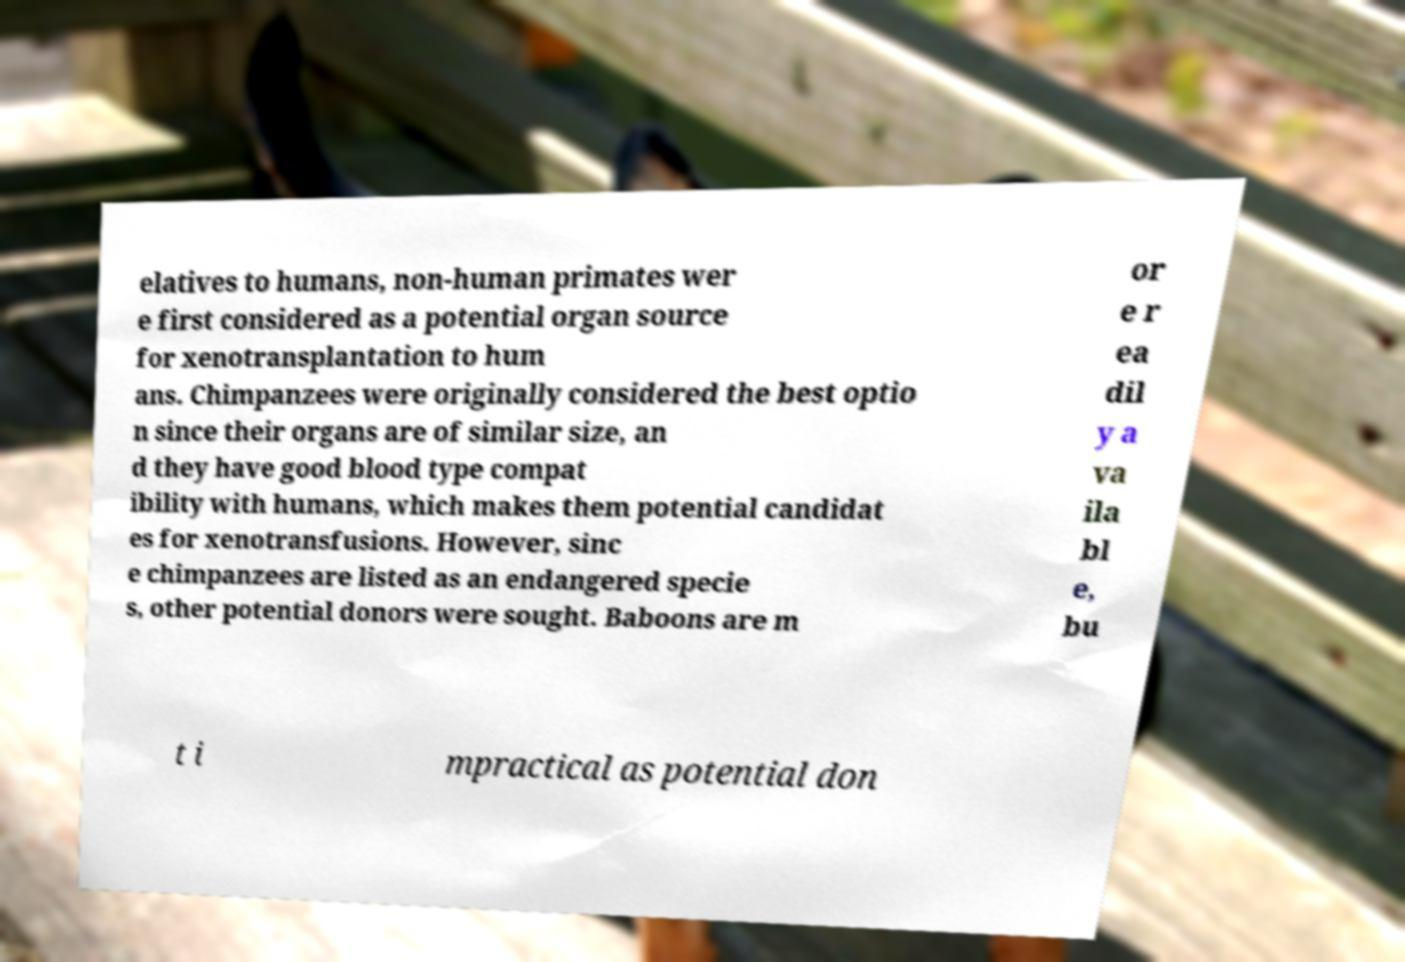For documentation purposes, I need the text within this image transcribed. Could you provide that? elatives to humans, non-human primates wer e first considered as a potential organ source for xenotransplantation to hum ans. Chimpanzees were originally considered the best optio n since their organs are of similar size, an d they have good blood type compat ibility with humans, which makes them potential candidat es for xenotransfusions. However, sinc e chimpanzees are listed as an endangered specie s, other potential donors were sought. Baboons are m or e r ea dil y a va ila bl e, bu t i mpractical as potential don 